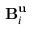<formula> <loc_0><loc_0><loc_500><loc_500>B _ { i } ^ { u }</formula> 